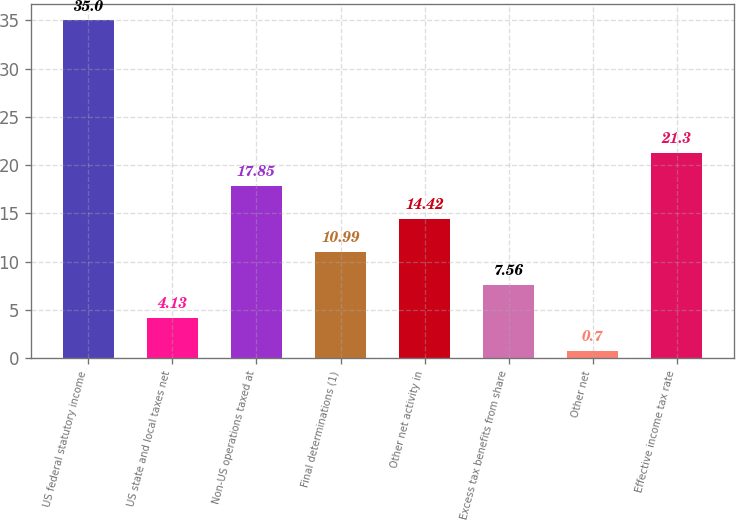Convert chart. <chart><loc_0><loc_0><loc_500><loc_500><bar_chart><fcel>US federal statutory income<fcel>US state and local taxes net<fcel>Non-US operations taxed at<fcel>Final determinations (1)<fcel>Other net activity in<fcel>Excess tax benefits from share<fcel>Other net<fcel>Effective income tax rate<nl><fcel>35<fcel>4.13<fcel>17.85<fcel>10.99<fcel>14.42<fcel>7.56<fcel>0.7<fcel>21.3<nl></chart> 